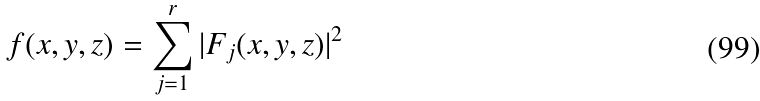Convert formula to latex. <formula><loc_0><loc_0><loc_500><loc_500>f ( x , y , z ) = \sum _ { j = 1 } ^ { r } | F _ { j } ( x , y , z ) | ^ { 2 }</formula> 